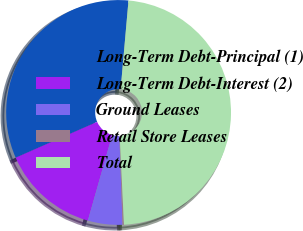Convert chart. <chart><loc_0><loc_0><loc_500><loc_500><pie_chart><fcel>Long-Term Debt-Principal (1)<fcel>Long-Term Debt-Interest (2)<fcel>Ground Leases<fcel>Retail Store Leases<fcel>Total<nl><fcel>33.0%<fcel>14.0%<fcel>4.97%<fcel>0.2%<fcel>47.84%<nl></chart> 